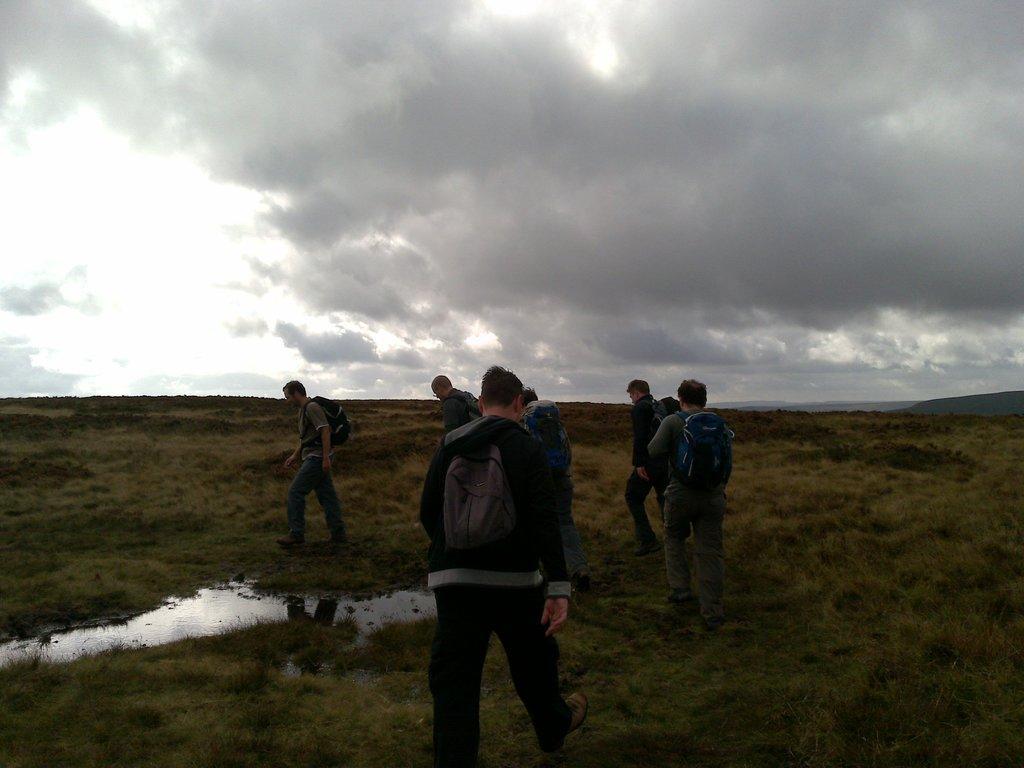Could you give a brief overview of what you see in this image? In this image, we can see people wearing bags and are walking on the ground and there is water. At the top, there are clouds in the sky. 